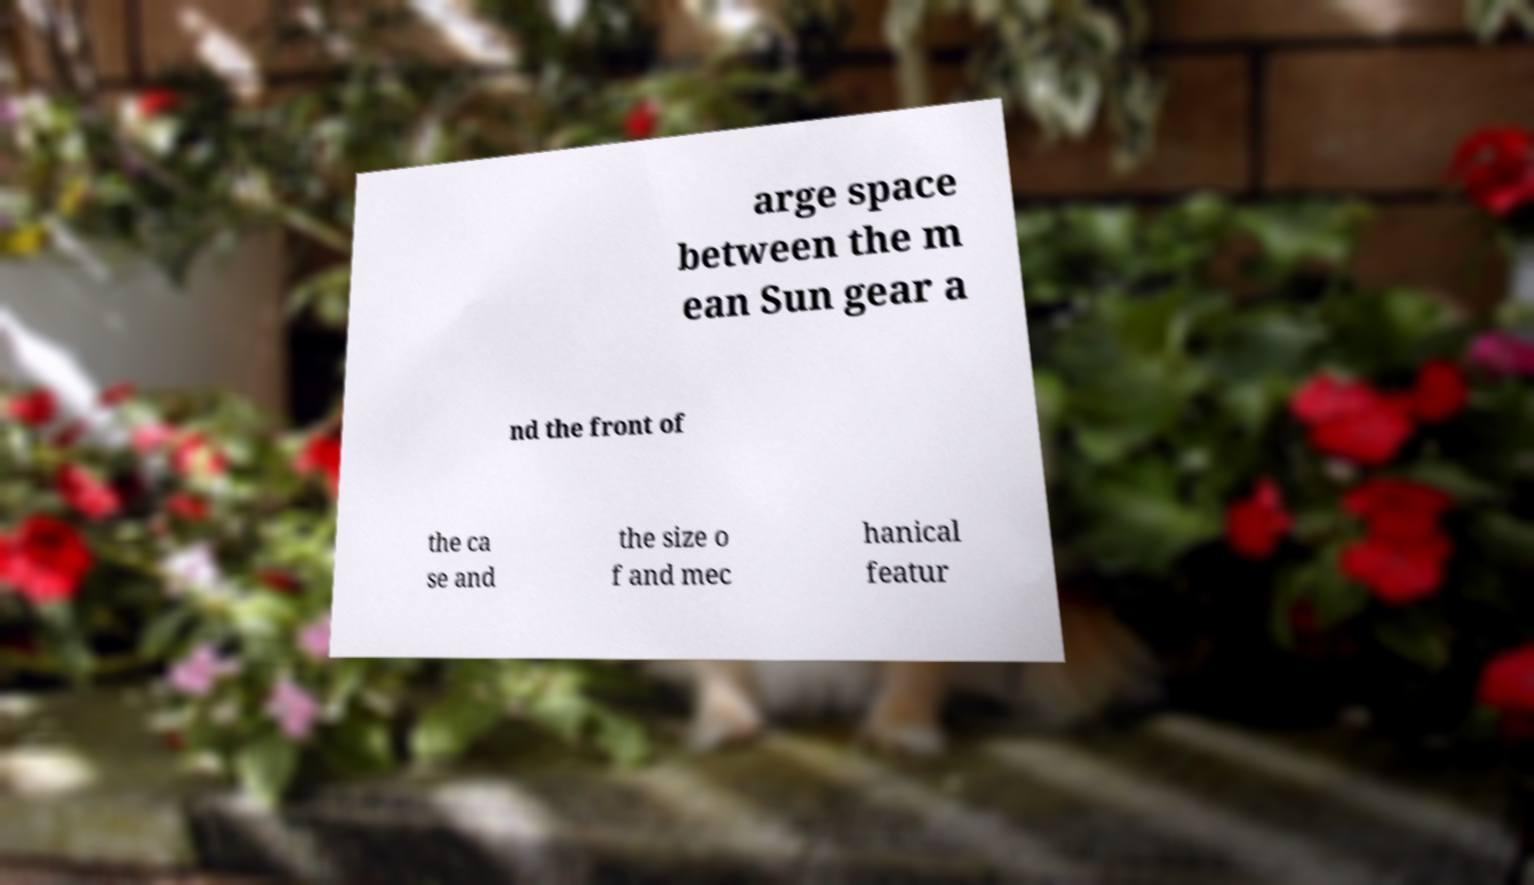Could you assist in decoding the text presented in this image and type it out clearly? arge space between the m ean Sun gear a nd the front of the ca se and the size o f and mec hanical featur 